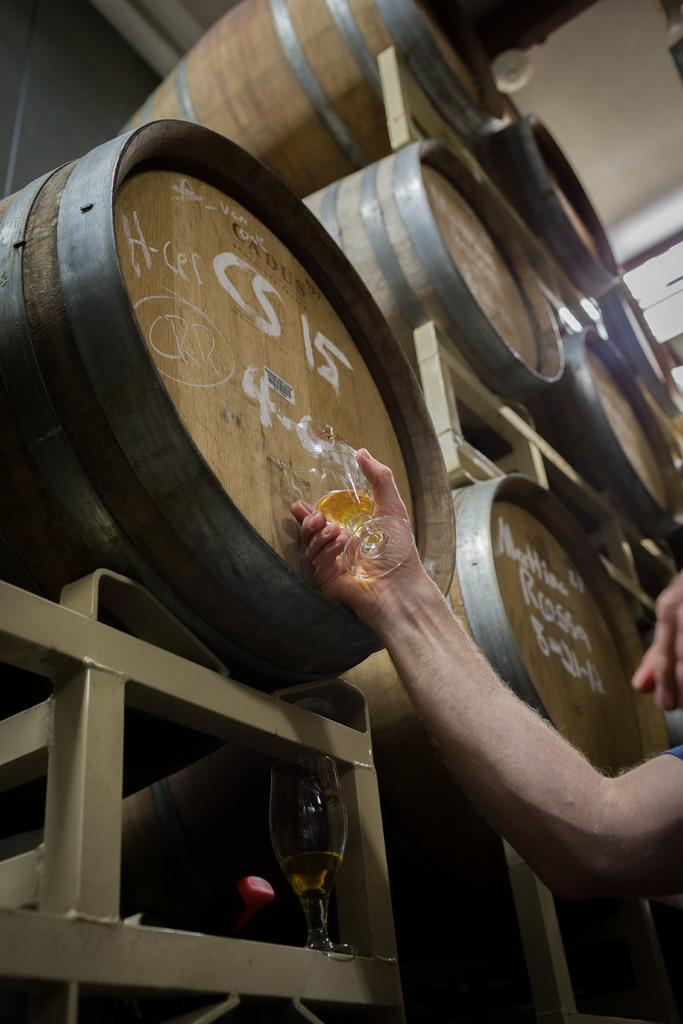<image>
Create a compact narrative representing the image presented. A man gets his beer from a barrel labeled "Cadus" 